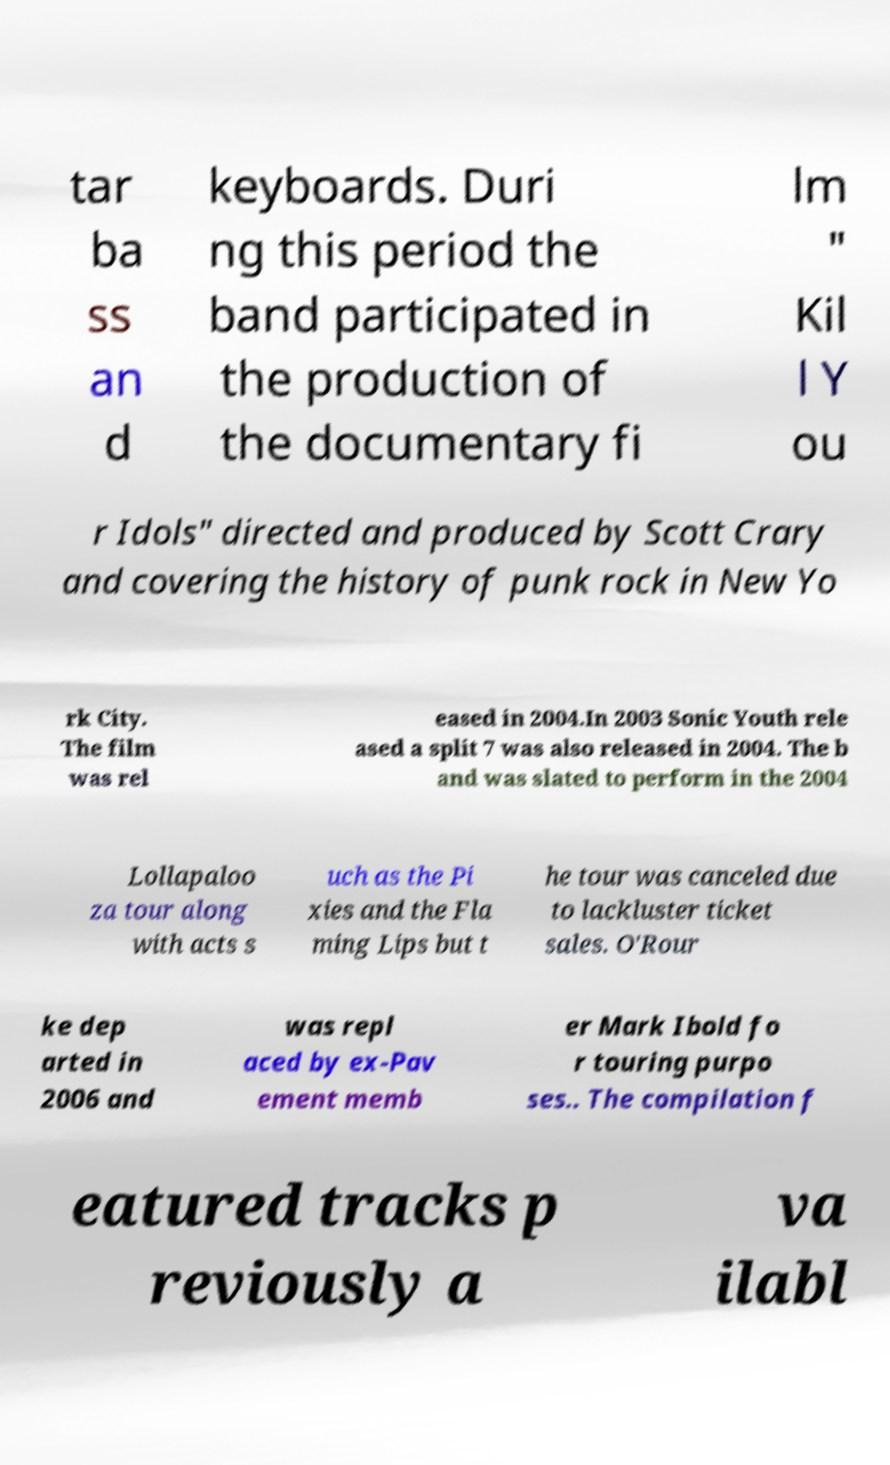What messages or text are displayed in this image? I need them in a readable, typed format. tar ba ss an d keyboards. Duri ng this period the band participated in the production of the documentary fi lm " Kil l Y ou r Idols" directed and produced by Scott Crary and covering the history of punk rock in New Yo rk City. The film was rel eased in 2004.In 2003 Sonic Youth rele ased a split 7 was also released in 2004. The b and was slated to perform in the 2004 Lollapaloo za tour along with acts s uch as the Pi xies and the Fla ming Lips but t he tour was canceled due to lackluster ticket sales. O'Rour ke dep arted in 2006 and was repl aced by ex-Pav ement memb er Mark Ibold fo r touring purpo ses.. The compilation f eatured tracks p reviously a va ilabl 